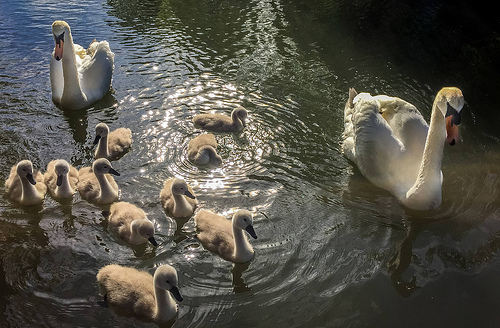<image>
Can you confirm if the duck is to the left of the water? No. The duck is not to the left of the water. From this viewpoint, they have a different horizontal relationship. Where is the swan in relation to the water? Is it under the water? No. The swan is not positioned under the water. The vertical relationship between these objects is different. 